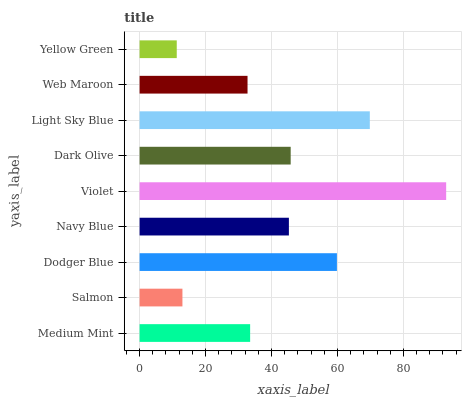Is Yellow Green the minimum?
Answer yes or no. Yes. Is Violet the maximum?
Answer yes or no. Yes. Is Salmon the minimum?
Answer yes or no. No. Is Salmon the maximum?
Answer yes or no. No. Is Medium Mint greater than Salmon?
Answer yes or no. Yes. Is Salmon less than Medium Mint?
Answer yes or no. Yes. Is Salmon greater than Medium Mint?
Answer yes or no. No. Is Medium Mint less than Salmon?
Answer yes or no. No. Is Navy Blue the high median?
Answer yes or no. Yes. Is Navy Blue the low median?
Answer yes or no. Yes. Is Dodger Blue the high median?
Answer yes or no. No. Is Dodger Blue the low median?
Answer yes or no. No. 